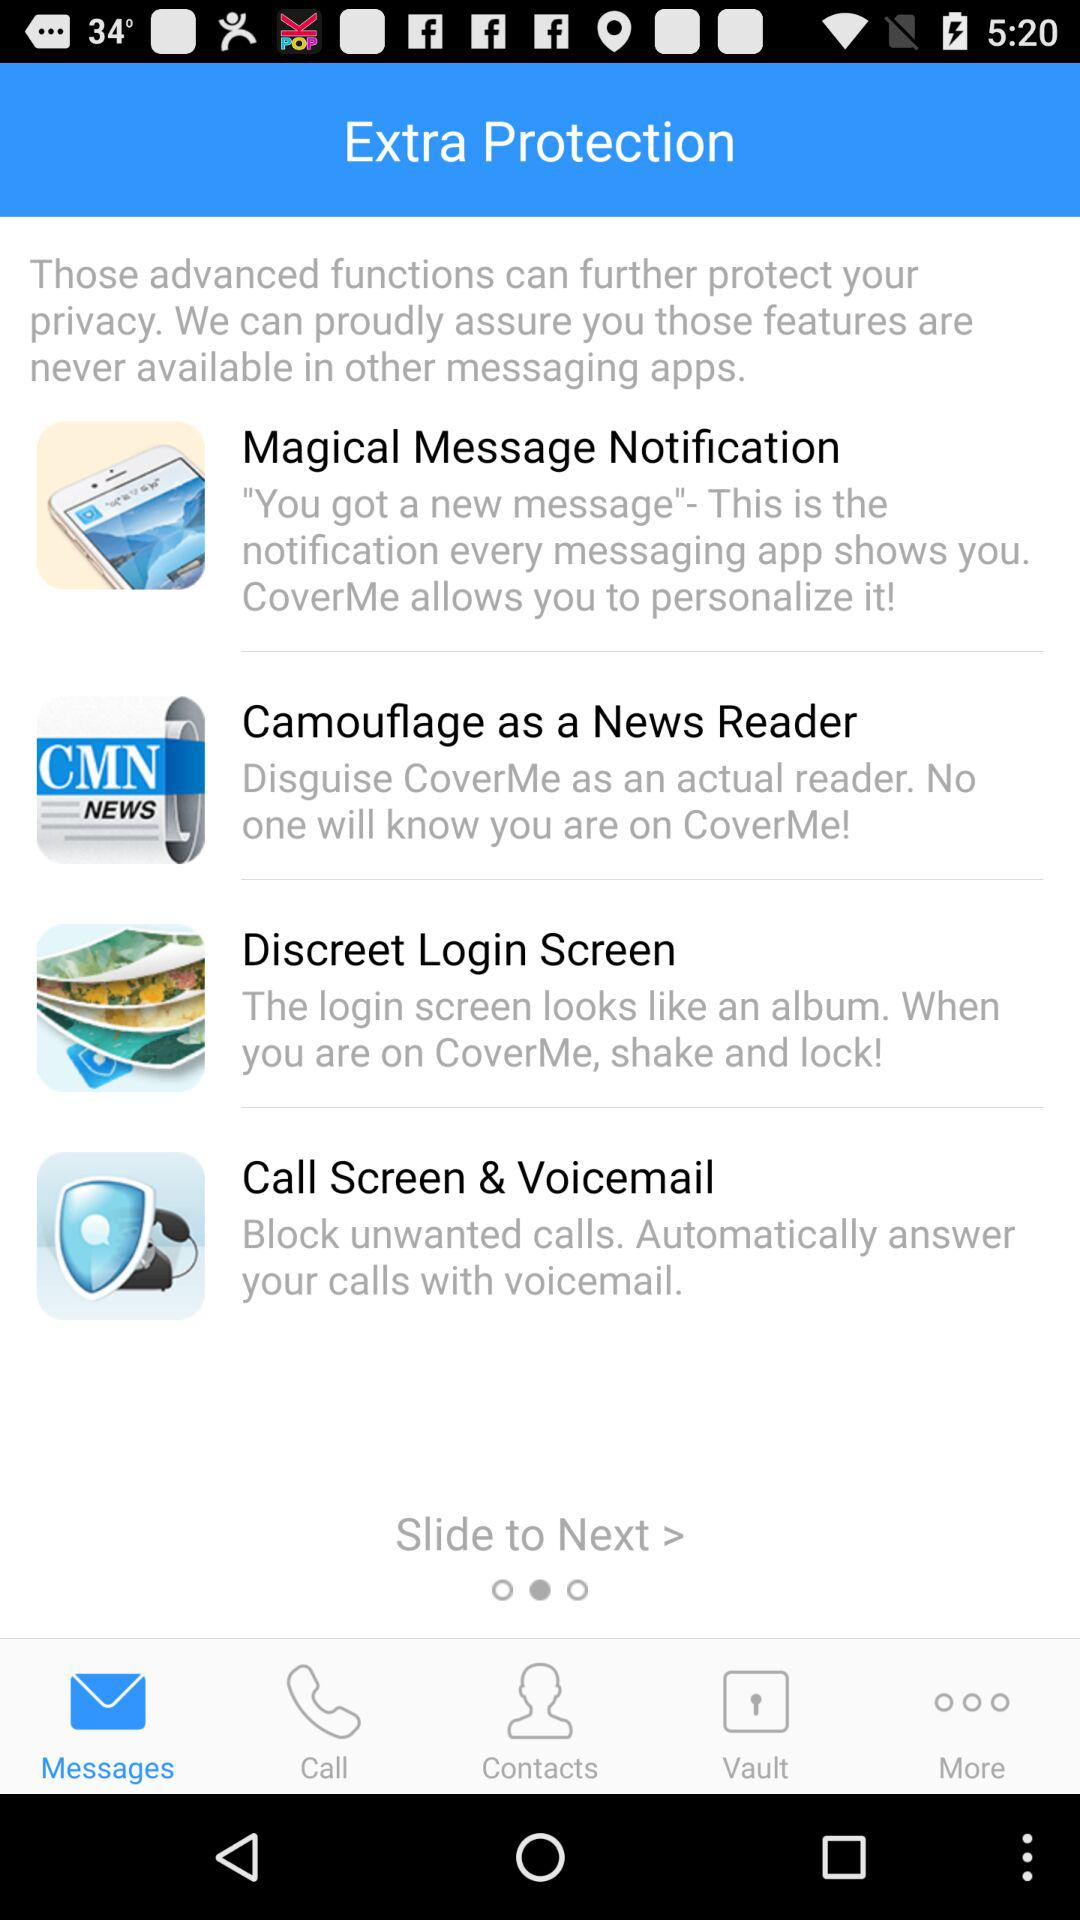What is the application name?
When the provided information is insufficient, respond with <no answer>. <no answer> 